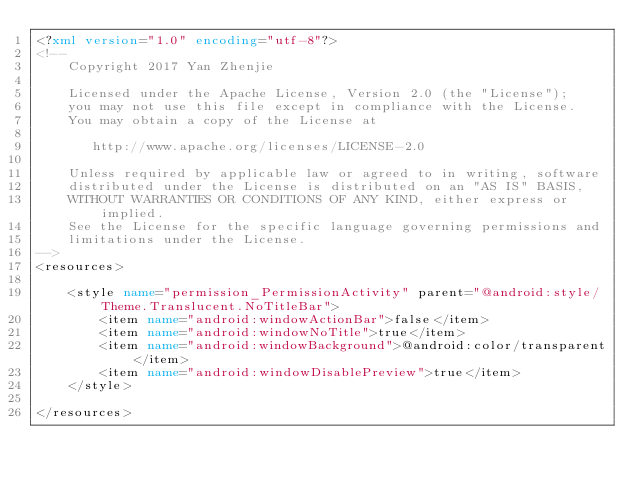<code> <loc_0><loc_0><loc_500><loc_500><_XML_><?xml version="1.0" encoding="utf-8"?>
<!--
    Copyright 2017 Yan Zhenjie

    Licensed under the Apache License, Version 2.0 (the "License");
    you may not use this file except in compliance with the License.
    You may obtain a copy of the License at

       http://www.apache.org/licenses/LICENSE-2.0

    Unless required by applicable law or agreed to in writing, software
    distributed under the License is distributed on an "AS IS" BASIS,
    WITHOUT WARRANTIES OR CONDITIONS OF ANY KIND, either express or implied.
    See the License for the specific language governing permissions and
    limitations under the License.
-->
<resources>

    <style name="permission_PermissionActivity" parent="@android:style/Theme.Translucent.NoTitleBar">
        <item name="android:windowActionBar">false</item>
        <item name="android:windowNoTitle">true</item>
        <item name="android:windowBackground">@android:color/transparent</item>
        <item name="android:windowDisablePreview">true</item>
    </style>

</resources></code> 